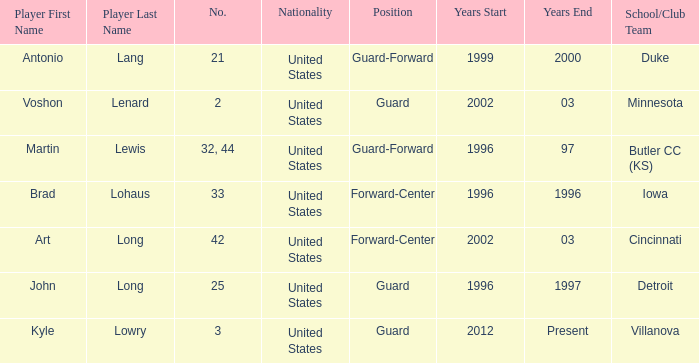What school did player number 21 play for? Duke. 